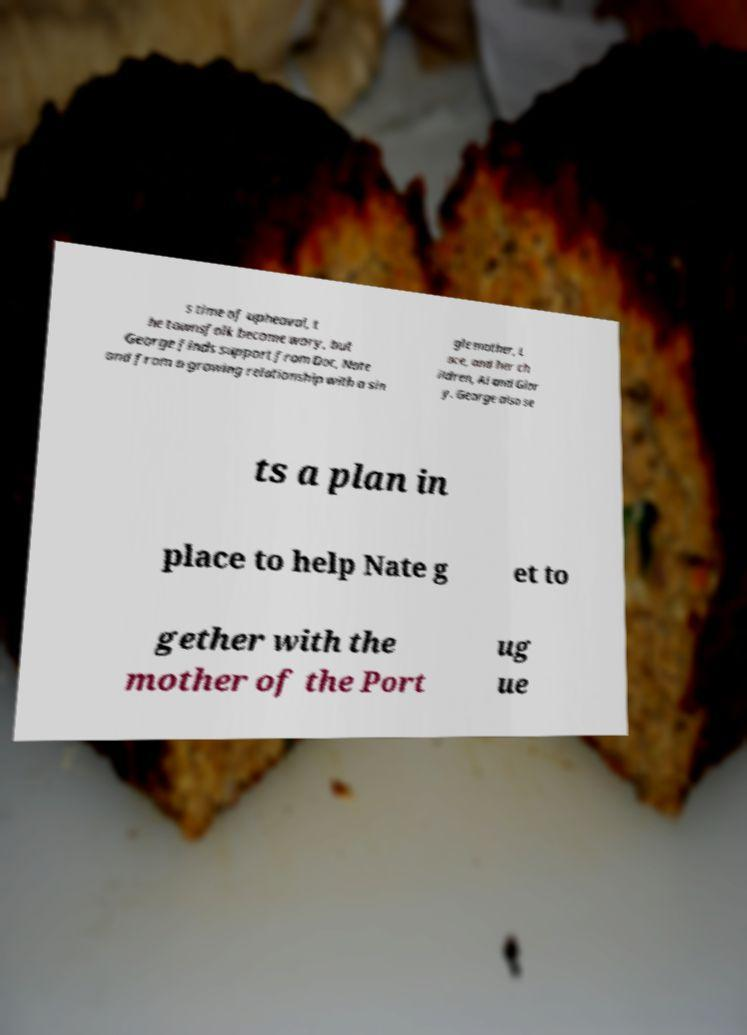Can you accurately transcribe the text from the provided image for me? s time of upheaval, t he townsfolk become wary, but George finds support from Doc, Nate and from a growing relationship with a sin gle mother, L ace, and her ch ildren, Al and Glor y. George also se ts a plan in place to help Nate g et to gether with the mother of the Port ug ue 